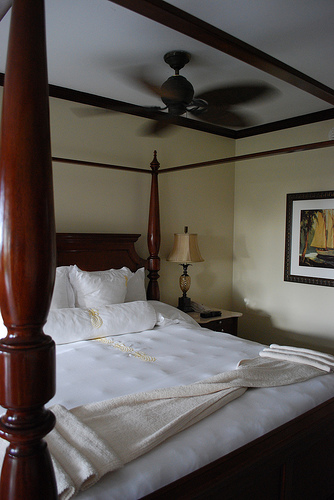<image>
Is the painting above the bed? No. The painting is not positioned above the bed. The vertical arrangement shows a different relationship. 